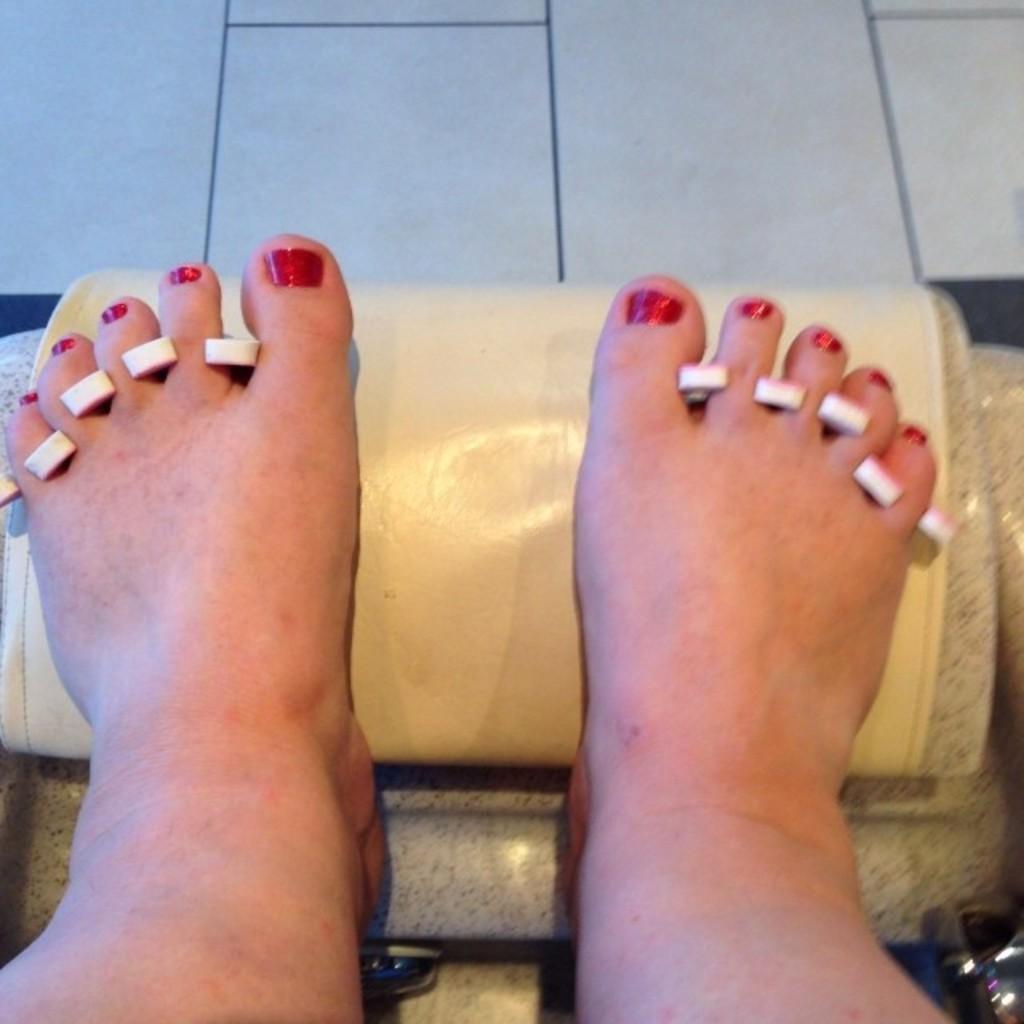Could you give a brief overview of what you see in this image? In this image we can see legs of a person and it is kept on an object. Between the fingers we can see white color things. 